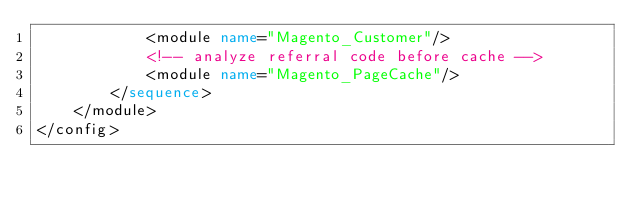Convert code to text. <code><loc_0><loc_0><loc_500><loc_500><_XML_>            <module name="Magento_Customer"/>
            <!-- analyze referral code before cache -->
            <module name="Magento_PageCache"/>
        </sequence>
    </module>
</config></code> 